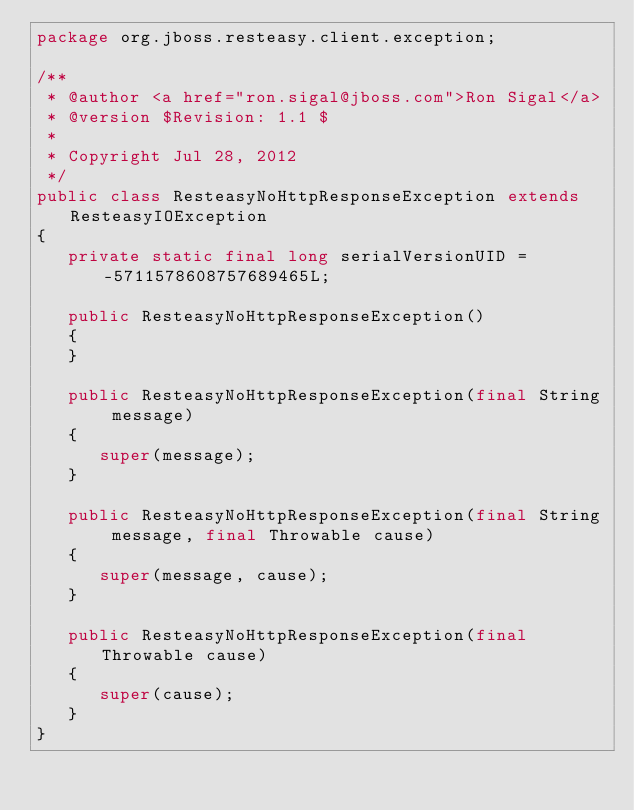<code> <loc_0><loc_0><loc_500><loc_500><_Java_>package org.jboss.resteasy.client.exception;

/**
 * @author <a href="ron.sigal@jboss.com">Ron Sigal</a>
 * @version $Revision: 1.1 $
 *
 * Copyright Jul 28, 2012
 */
public class ResteasyNoHttpResponseException extends ResteasyIOException
{
   private static final long serialVersionUID = -5711578608757689465L;

   public ResteasyNoHttpResponseException()
   {
   }

   public ResteasyNoHttpResponseException(final String message)
   {
      super(message);
   }

   public ResteasyNoHttpResponseException(final String message, final Throwable cause)
   {
      super(message, cause);
   }

   public ResteasyNoHttpResponseException(final Throwable cause)
   {
      super(cause);
   }
}
</code> 